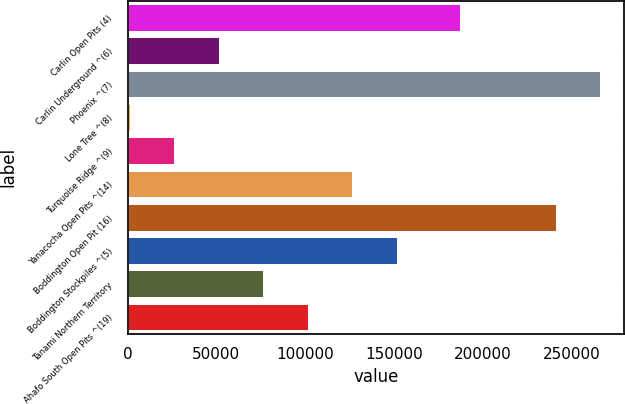Convert chart. <chart><loc_0><loc_0><loc_500><loc_500><bar_chart><fcel>Carlin Open Pits (4)<fcel>Carlin Underground ^(6)<fcel>Phoenix ^(7)<fcel>Lone Tree ^(8)<fcel>Turquoise Ridge ^(9)<fcel>Yanacocha Open Pits ^(14)<fcel>Boddington Open Pit (16)<fcel>Boddington Stockpiles ^(5)<fcel>Tanami Northern Territory<fcel>Ahafo South Open Pits ^(19)<nl><fcel>187400<fcel>51320<fcel>266260<fcel>1200<fcel>26260<fcel>126500<fcel>241200<fcel>151560<fcel>76380<fcel>101440<nl></chart> 